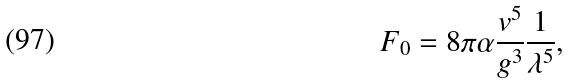Convert formula to latex. <formula><loc_0><loc_0><loc_500><loc_500>F _ { 0 } = 8 \pi \alpha \frac { v ^ { 5 } } { g ^ { 3 } } \frac { 1 } { \lambda ^ { 5 } } ,</formula> 